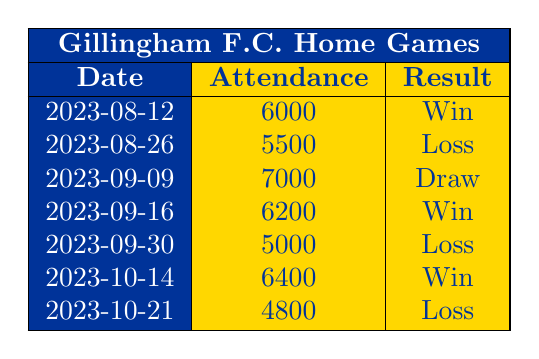What was the attendance for the game on 2023-09-30? The table shows that the attendance on 2023-09-30 was 5000.
Answer: 5000 How many matches did Gillingham F.C. win at home in this period? The table lists three matches with the result "Win" which are on 2023-08-12, 2023-09-16, and 2023-10-14.
Answer: 3 What is the average attendance for matches that resulted in a loss? For losses, the attendances are 5500 (2023-08-26), 5000 (2023-09-30), and 4800 (2023-10-21). The total attendance for losses is (5500 + 5000 + 4800) = 15300, and there are 3 matches. Thus, the average is 15300 / 3 = 5100.
Answer: 5100 Did Gillingham F.C. have a higher attendance in matches they won versus those they lost? In the winning matches, the attendances are 6000, 6200, and 6400 (average 6200). In the losing matches, the average attendance is 5100. Thus, the average attendance in winning matches is indeed higher than in losing matches.
Answer: Yes Which match had the highest attendance, and what was the result? The highest attendance in the table is 7000 for the match on 2023-09-09, which resulted in a Draw.
Answer: 7000, Draw What is the difference in attendance between the match with the highest and lowest turnout? The highest attendance is 7000 (2023-09-09) and the lowest is 4800 (2023-10-21). The difference is 7000 - 4800 = 2200.
Answer: 2200 Is there a match where the attendance was above 6000 and the result was not a win? The match on 2023-09-09 had an attendance of 7000 and resulted in a Draw, which is not a win. Thus, there is such a match.
Answer: Yes How many matches ended in a draw in the given data? There is only one match listed that ended in a Draw, which is on 2023-09-09.
Answer: 1 What was the total attendance across all matches played? Summing the attendance figures gives 6000 + 5500 + 7000 + 6200 + 5000 + 6400 + 4800 = 41900.
Answer: 41900 